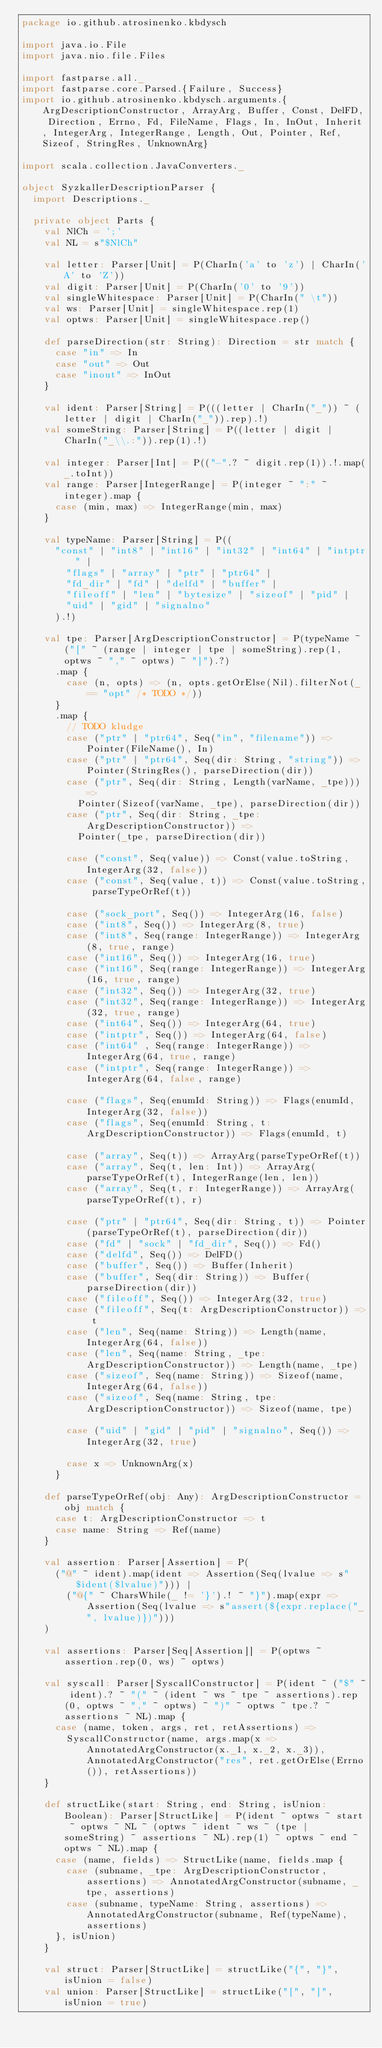Convert code to text. <code><loc_0><loc_0><loc_500><loc_500><_Scala_>package io.github.atrosinenko.kbdysch

import java.io.File
import java.nio.file.Files

import fastparse.all._
import fastparse.core.Parsed.{Failure, Success}
import io.github.atrosinenko.kbdysch.arguments.{ArgDescriptionConstructor, ArrayArg, Buffer, Const, DelFD, Direction, Errno, Fd, FileName, Flags, In, InOut, Inherit, IntegerArg, IntegerRange, Length, Out, Pointer, Ref, Sizeof, StringRes, UnknownArg}

import scala.collection.JavaConverters._

object SyzkallerDescriptionParser {
  import Descriptions._

  private object Parts {
    val NlCh = ';'
    val NL = s"$NlCh"

    val letter: Parser[Unit] = P(CharIn('a' to 'z') | CharIn('A' to 'Z'))
    val digit: Parser[Unit] = P(CharIn('0' to '9'))
    val singleWhitespace: Parser[Unit] = P(CharIn(" \t"))
    val ws: Parser[Unit] = singleWhitespace.rep(1)
    val optws: Parser[Unit] = singleWhitespace.rep()

    def parseDirection(str: String): Direction = str match {
      case "in" => In
      case "out" => Out
      case "inout" => InOut
    }

    val ident: Parser[String] = P(((letter | CharIn("_")) ~ (letter | digit | CharIn("_")).rep).!)
    val someString: Parser[String] = P((letter | digit | CharIn("_\\.:")).rep(1).!)

    val integer: Parser[Int] = P(("-".? ~ digit.rep(1)).!.map(_.toInt))
    val range: Parser[IntegerRange] = P(integer ~ ":" ~ integer).map {
      case (min, max) => IntegerRange(min, max)
    }

    val typeName: Parser[String] = P((
      "const" | "int8" | "int16" | "int32" | "int64" | "intptr" |
        "flags" | "array" | "ptr" | "ptr64" |
        "fd_dir" | "fd" | "delfd" | "buffer" |
        "fileoff" | "len" | "bytesize" | "sizeof" | "pid" |
        "uid" | "gid" | "signalno"
      ).!)

    val tpe: Parser[ArgDescriptionConstructor] = P(typeName ~ ("[" ~ (range | integer | tpe | someString).rep(1, optws ~ "," ~ optws) ~ "]").?)
      .map {
        case (n, opts) => (n, opts.getOrElse(Nil).filterNot(_ == "opt" /* TODO */))
      }
      .map {
        // TODO kludge
        case ("ptr" | "ptr64", Seq("in", "filename")) => Pointer(FileName(), In)
        case ("ptr" | "ptr64", Seq(dir: String, "string")) => Pointer(StringRes(), parseDirection(dir))
        case ("ptr", Seq(dir: String, Length(varName, _tpe))) =>
          Pointer(Sizeof(varName, _tpe), parseDirection(dir))
        case ("ptr", Seq(dir: String, _tpe: ArgDescriptionConstructor)) =>
          Pointer(_tpe, parseDirection(dir))

        case ("const", Seq(value)) => Const(value.toString, IntegerArg(32, false))
        case ("const", Seq(value, t)) => Const(value.toString, parseTypeOrRef(t))

        case ("sock_port", Seq()) => IntegerArg(16, false)
        case ("int8", Seq()) => IntegerArg(8, true)
        case ("int8", Seq(range: IntegerRange)) => IntegerArg(8, true, range)
        case ("int16", Seq()) => IntegerArg(16, true)
        case ("int16", Seq(range: IntegerRange)) => IntegerArg(16, true, range)
        case ("int32", Seq()) => IntegerArg(32, true)
        case ("int32", Seq(range: IntegerRange)) => IntegerArg(32, true, range)
        case ("int64", Seq()) => IntegerArg(64, true)
        case ("intptr", Seq()) => IntegerArg(64, false)
        case ("int64" , Seq(range: IntegerRange)) => IntegerArg(64, true, range)
        case ("intptr", Seq(range: IntegerRange)) => IntegerArg(64, false, range)

        case ("flags", Seq(enumId: String)) => Flags(enumId, IntegerArg(32, false))
        case ("flags", Seq(enumId: String, t: ArgDescriptionConstructor)) => Flags(enumId, t)

        case ("array", Seq(t)) => ArrayArg(parseTypeOrRef(t))
        case ("array", Seq(t, len: Int)) => ArrayArg(parseTypeOrRef(t), IntegerRange(len, len))
        case ("array", Seq(t, r: IntegerRange)) => ArrayArg(parseTypeOrRef(t), r)

        case ("ptr" | "ptr64", Seq(dir: String, t)) => Pointer(parseTypeOrRef(t), parseDirection(dir))
        case ("fd" | "sock" | "fd_dir", Seq()) => Fd()
        case ("delfd", Seq()) => DelFD()
        case ("buffer", Seq()) => Buffer(Inherit)
        case ("buffer", Seq(dir: String)) => Buffer(parseDirection(dir))
        case ("fileoff", Seq()) => IntegerArg(32, true)
        case ("fileoff", Seq(t: ArgDescriptionConstructor)) => t
        case ("len", Seq(name: String)) => Length(name, IntegerArg(64, false))
        case ("len", Seq(name: String, _tpe: ArgDescriptionConstructor)) => Length(name, _tpe)
        case ("sizeof", Seq(name: String)) => Sizeof(name, IntegerArg(64, false))
        case ("sizeof", Seq(name: String, tpe: ArgDescriptionConstructor)) => Sizeof(name, tpe)

        case ("uid" | "gid" | "pid" | "signalno", Seq()) => IntegerArg(32, true)

        case x => UnknownArg(x)
      }

    def parseTypeOrRef(obj: Any): ArgDescriptionConstructor = obj match {
      case t: ArgDescriptionConstructor => t
      case name: String => Ref(name)
    }

    val assertion: Parser[Assertion] = P(
      ("@" ~ ident).map(ident => Assertion(Seq(lvalue => s"$ident($lvalue)"))) |
        ("@{" ~ CharsWhile(_ != '}').! ~ "}").map(expr => Assertion(Seq(lvalue => s"assert(${expr.replace("_", lvalue)})")))
    )

    val assertions: Parser[Seq[Assertion]] = P(optws ~ assertion.rep(0, ws) ~ optws)

    val syscall: Parser[SyscallConstructor] = P(ident ~ ("$" ~ ident).? ~ "(" ~ (ident ~ ws ~ tpe ~ assertions).rep(0, optws ~ "," ~ optws) ~ ")" ~ optws ~ tpe.? ~ assertions ~ NL).map {
      case (name, token, args, ret, retAssertions) =>
        SyscallConstructor(name, args.map(x => AnnotatedArgConstructor(x._1, x._2, x._3)), AnnotatedArgConstructor("res", ret.getOrElse(Errno()), retAssertions))
    }

    def structLike(start: String, end: String, isUnion: Boolean): Parser[StructLike] = P(ident ~ optws ~ start ~ optws ~ NL ~ (optws ~ ident ~ ws ~ (tpe | someString) ~ assertions ~ NL).rep(1) ~ optws ~ end ~ optws ~ NL).map {
      case (name, fields) => StructLike(name, fields.map {
        case (subname, _tpe: ArgDescriptionConstructor, assertions) => AnnotatedArgConstructor(subname, _tpe, assertions)
        case (subname, typeName: String, assertions) => AnnotatedArgConstructor(subname, Ref(typeName), assertions)
      }, isUnion)
    }

    val struct: Parser[StructLike] = structLike("{", "}", isUnion = false)
    val union: Parser[StructLike] = structLike("[", "]", isUnion = true)
</code> 